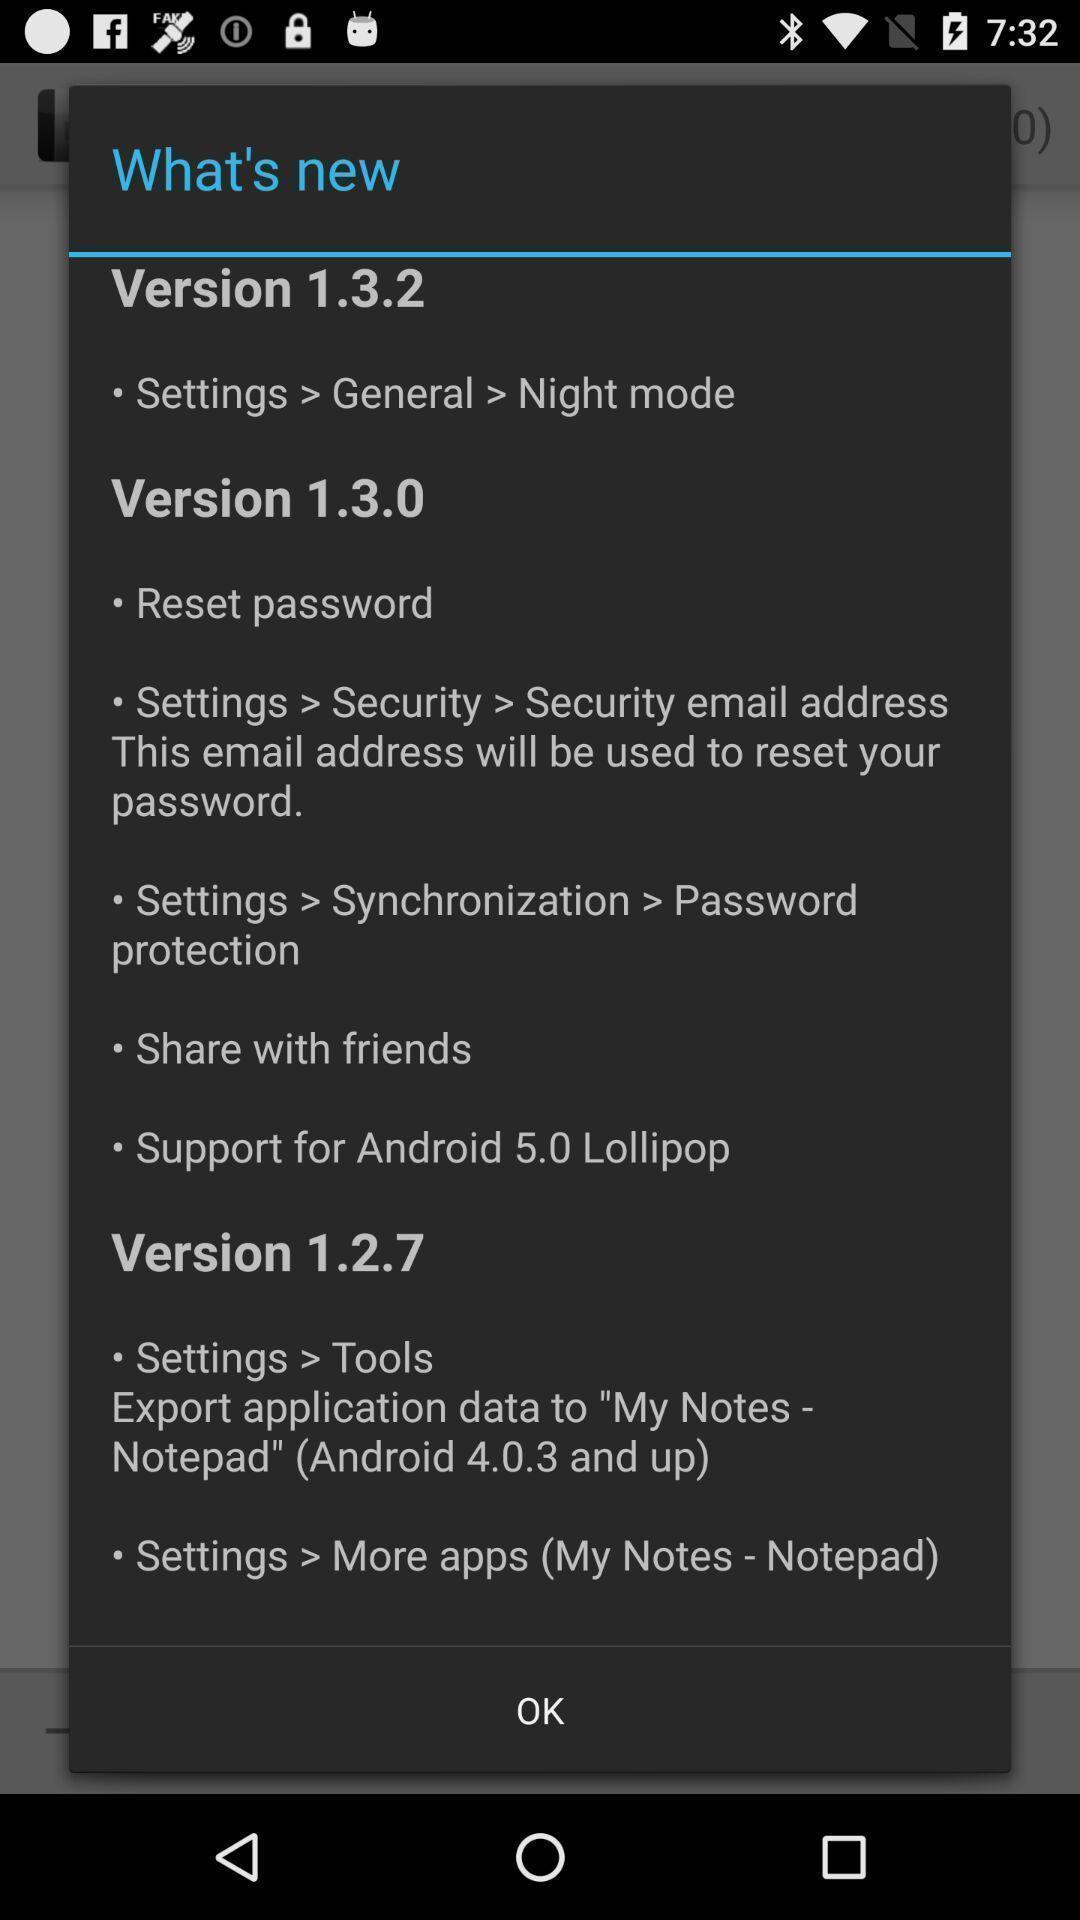Explain the elements present in this screenshot. Pop-up shows new version. 